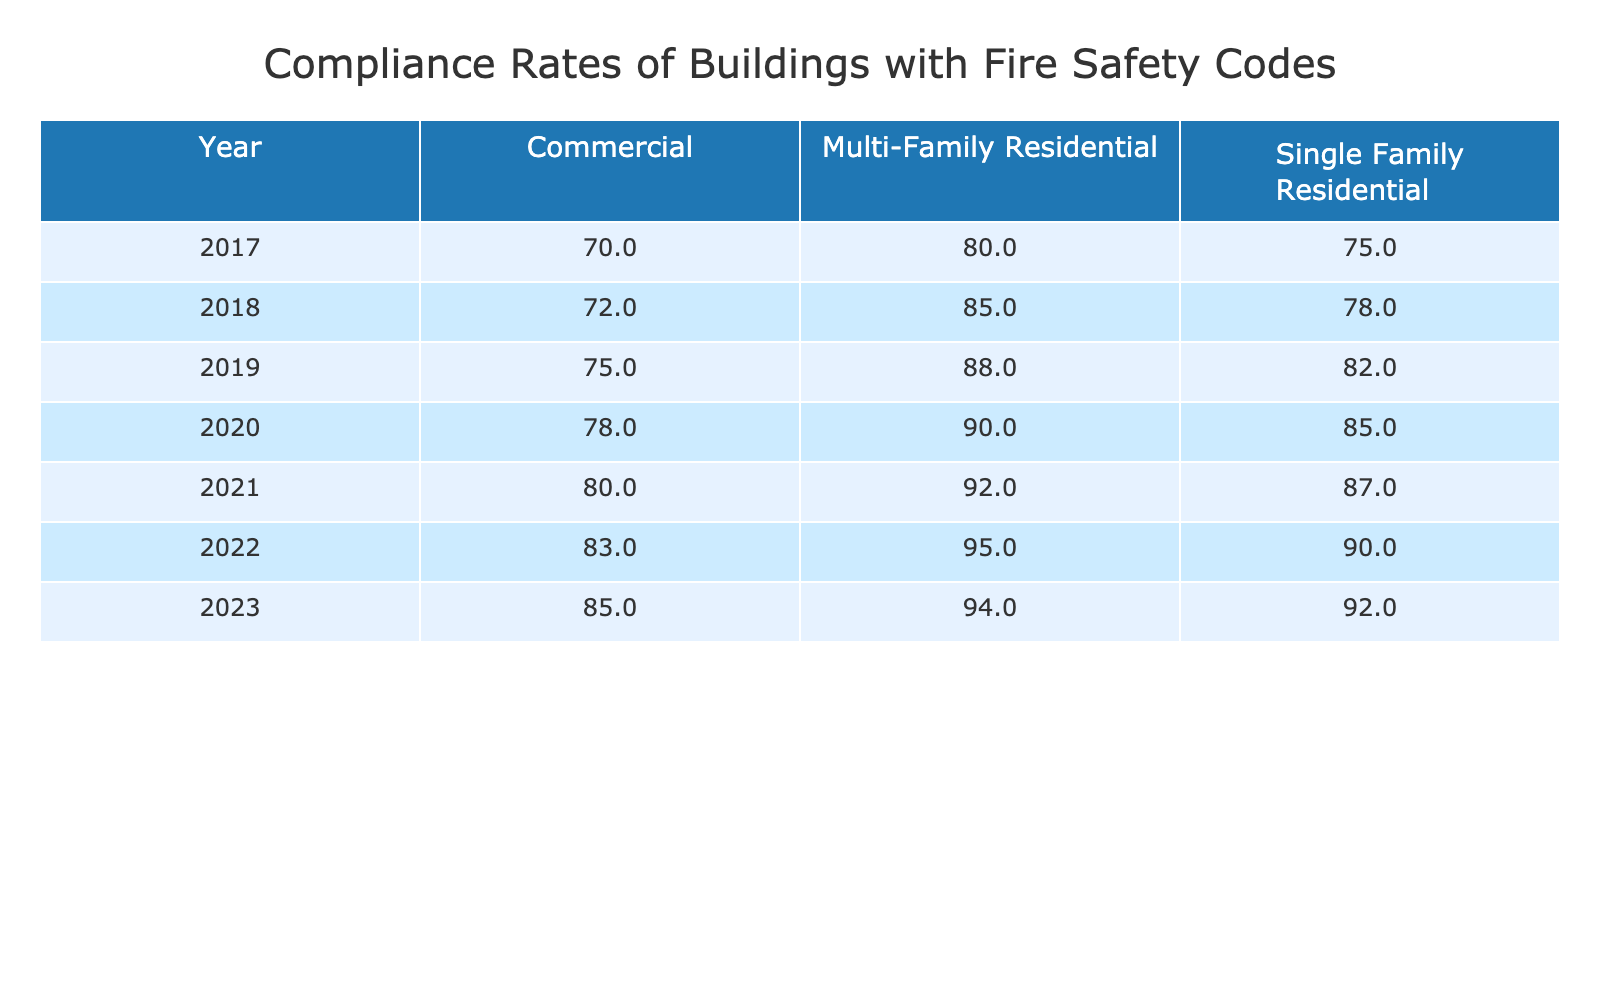What was the compliance rate for Multi-Family Residential buildings in 2019? In the table, I can find the row for the year 2019, and under the column for Multi-Family Residential, the compliance rate listed is 88%.
Answer: 88 Which year had the highest compliance rate for Single Family Residential buildings? Looking through the compliance rates for Single Family Residential buildings from 2017 to 2023, I see that the highest rate was in 2022 at 90%.
Answer: 2022 What is the average compliance rate for Commercial buildings from 2017 to 2023? I will sum up the compliance rates for Commercial buildings across the years: 70 + 72 + 75 + 78 + 80 + 83 + 85 = 463. There are 7 data points, so the average is 463/7 ≈ 66.14.
Answer: 66.14 Did the compliance rate for Multi-Family Residential buildings ever drop below 80%? By inspecting the Multi-Family Residential compliance rates from 2017 to 2023, I see that the lowest value was 80% in 2017, so it did not drop below 80%.
Answer: No In which year did the compliance rate for Commercial buildings see the highest increase from the previous year? I will compare the compliance rates for Commercial buildings year by year: 2017 (70) to 2018 (72) is a 2-point increase; 2018 (72) to 2019 (75) is a 3-point increase; 2019 (75) to 2020 (78) is a 3-point increase; 2020 (78) to 2021 (80) is a 2-point increase; 2021 (80) to 2022 (83) is a 3-point increase; and finally, 2022 (83) to 2023 (85) is a 2-point increase. The highest increase was from 2018 to 2019 with 3 points.
Answer: 2019 What was the difference in compliance rates between Single Family Residential and Multi-Family Residential in 2021? For the year 2021, Single Family Residential had a compliance rate of 87% and Multi-Family Residential had a compliance rate of 92%. The difference is 92 - 87 = 5%.
Answer: 5% Which building type had the most consistent compliance rate based on the data? Looking at the table, the Multi-Family Residential building type consistently had higher compliance rates and shows gradual increases each year, suggesting consistency without significant fluctuations.
Answer: Multi-Family Residential What is the compliance rate trend for Single Family Residential buildings from 2017 to 2023? I will analyze the compliance rates for Single Family Residential: 75% in 2017, 78% in 2018, increasing to 82% in 2019, then 85% in 2020, 87% in 2021, 90% in 2022 and finally 92% in 2023. The trend shows a steady increase each year.
Answer: Steady increase 